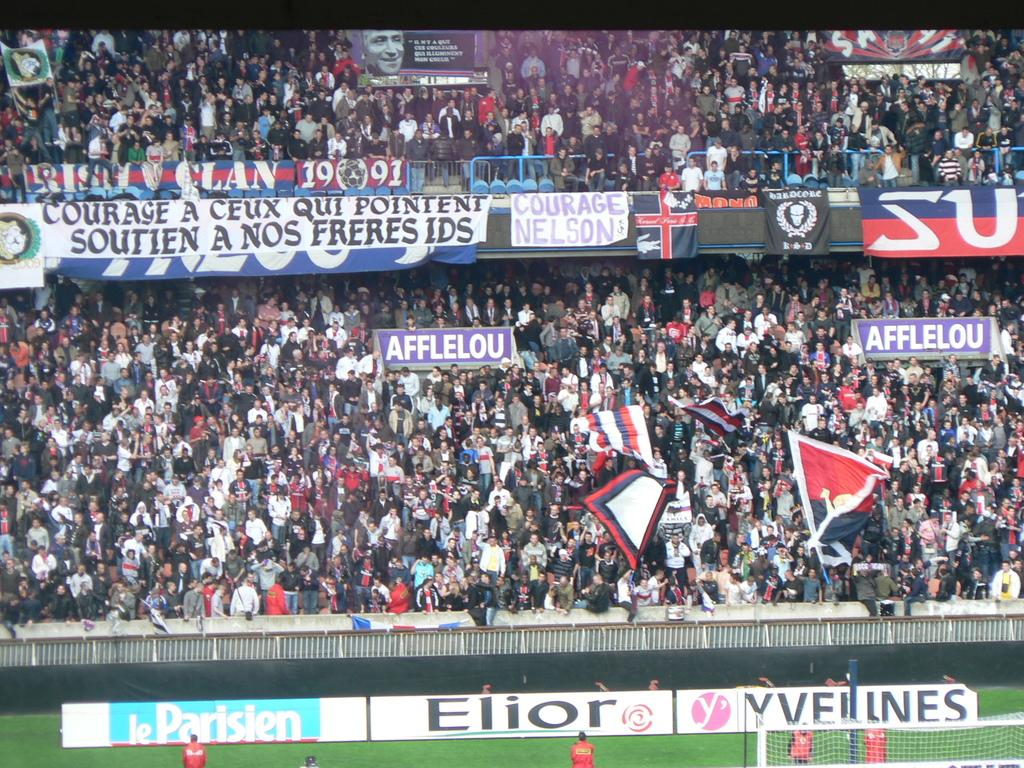Provide a one-sentence caption for the provided image. The crowd at a sporting event with logo banners displayed for Elior and other companies. 